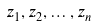Convert formula to latex. <formula><loc_0><loc_0><loc_500><loc_500>z _ { 1 } , z _ { 2 } , \dots , z _ { n }</formula> 